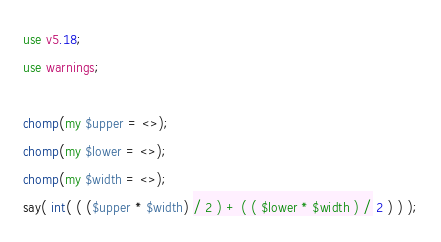<code> <loc_0><loc_0><loc_500><loc_500><_Perl_>use v5.18;
use warnings;

chomp(my $upper = <>);
chomp(my $lower = <>);
chomp(my $width = <>);
say( int( ( ($upper * $width) / 2 ) + ( ( $lower * $width ) / 2 ) ) );
</code> 